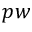Convert formula to latex. <formula><loc_0><loc_0><loc_500><loc_500>p w</formula> 